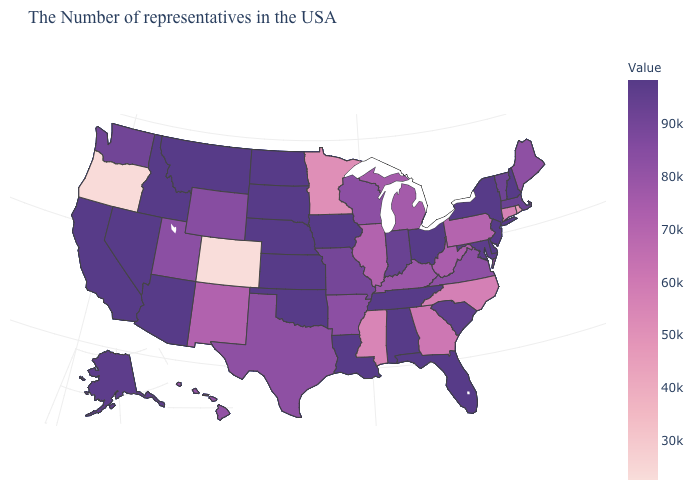Does Alabama have the highest value in the USA?
Short answer required. Yes. Among the states that border Illinois , which have the highest value?
Be succinct. Iowa. Does Vermont have the highest value in the Northeast?
Answer briefly. No. Does California have a higher value than Rhode Island?
Quick response, please. Yes. Does Illinois have the highest value in the MidWest?
Write a very short answer. No. 